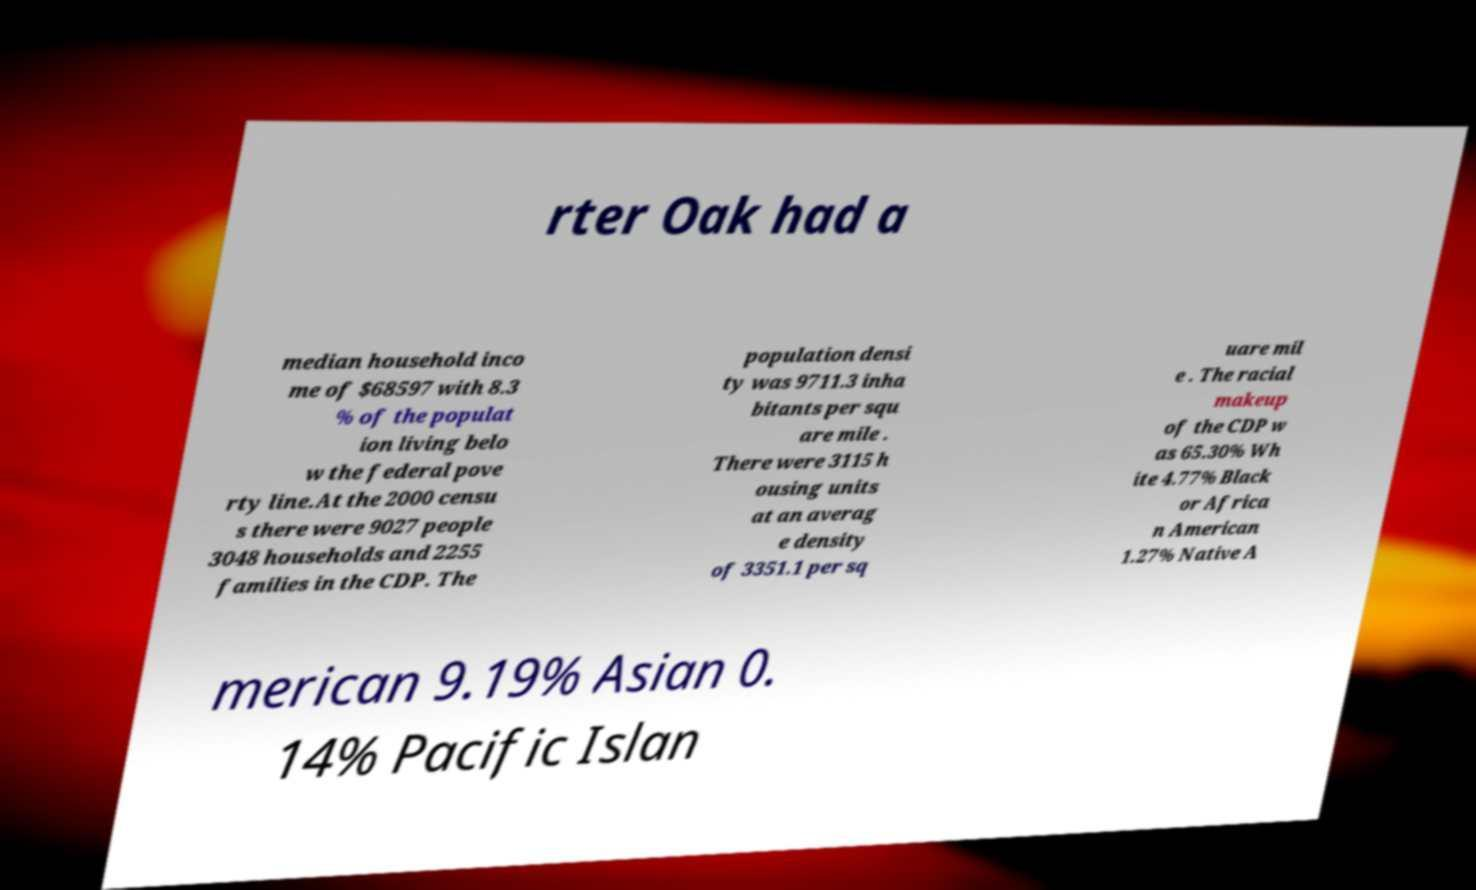Could you assist in decoding the text presented in this image and type it out clearly? rter Oak had a median household inco me of $68597 with 8.3 % of the populat ion living belo w the federal pove rty line.At the 2000 censu s there were 9027 people 3048 households and 2255 families in the CDP. The population densi ty was 9711.3 inha bitants per squ are mile . There were 3115 h ousing units at an averag e density of 3351.1 per sq uare mil e . The racial makeup of the CDP w as 65.30% Wh ite 4.77% Black or Africa n American 1.27% Native A merican 9.19% Asian 0. 14% Pacific Islan 